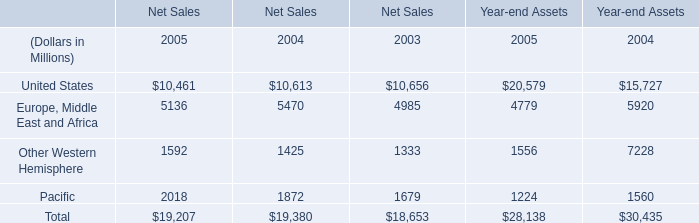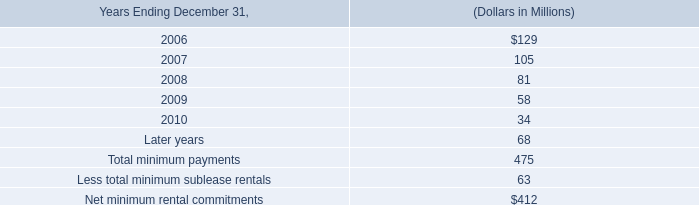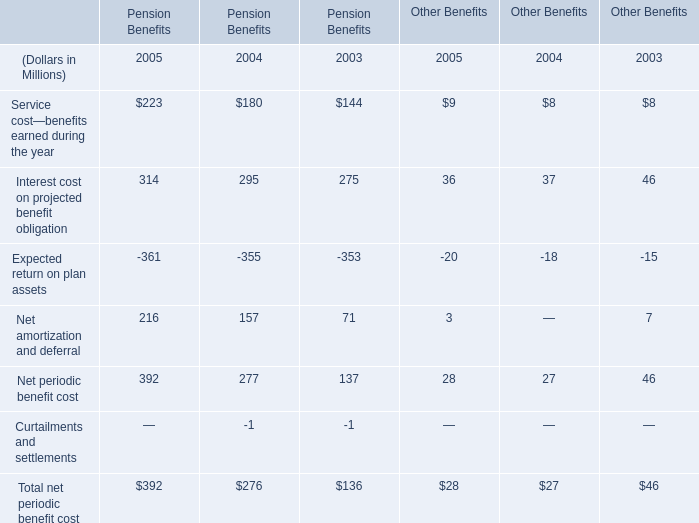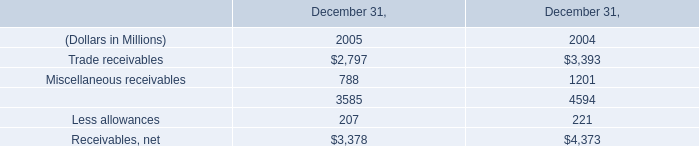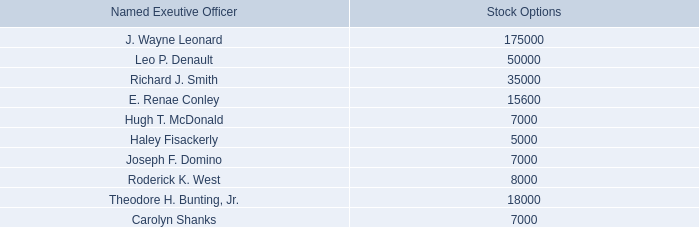what is the total value of stock options for leo p . denault , in millions? 
Computations: ((50000 * 108.20) / 1000000)
Answer: 5.41. 